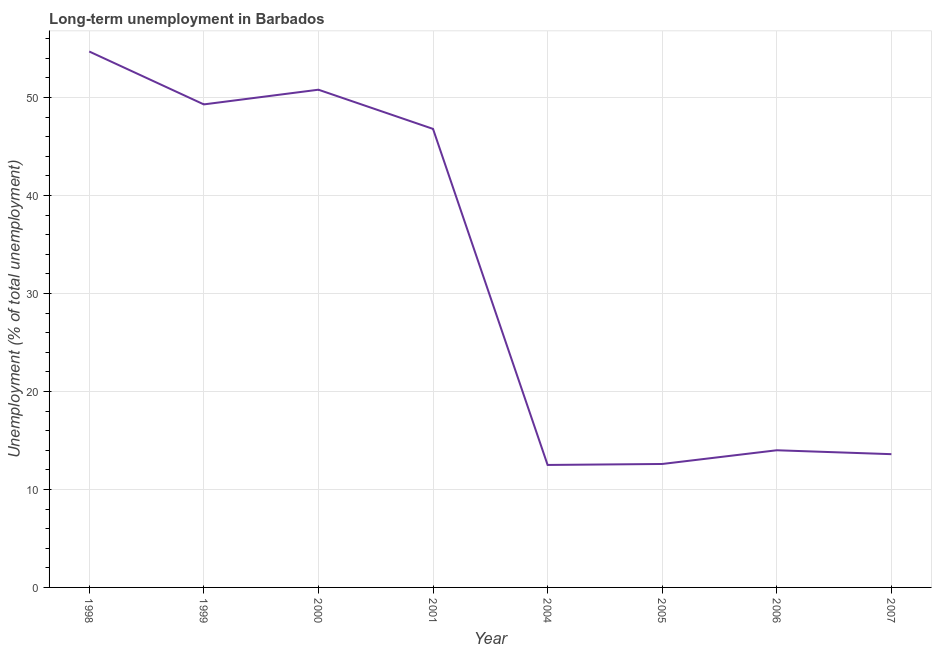What is the long-term unemployment in 1999?
Ensure brevity in your answer.  49.3. Across all years, what is the maximum long-term unemployment?
Keep it short and to the point. 54.7. Across all years, what is the minimum long-term unemployment?
Your response must be concise. 12.5. In which year was the long-term unemployment minimum?
Your response must be concise. 2004. What is the sum of the long-term unemployment?
Your answer should be compact. 254.3. What is the difference between the long-term unemployment in 2006 and 2007?
Make the answer very short. 0.4. What is the average long-term unemployment per year?
Provide a short and direct response. 31.79. What is the median long-term unemployment?
Your response must be concise. 30.4. What is the ratio of the long-term unemployment in 2004 to that in 2006?
Provide a succinct answer. 0.89. Is the long-term unemployment in 2000 less than that in 2007?
Ensure brevity in your answer.  No. What is the difference between the highest and the second highest long-term unemployment?
Ensure brevity in your answer.  3.9. Is the sum of the long-term unemployment in 1998 and 2007 greater than the maximum long-term unemployment across all years?
Offer a very short reply. Yes. What is the difference between the highest and the lowest long-term unemployment?
Keep it short and to the point. 42.2. In how many years, is the long-term unemployment greater than the average long-term unemployment taken over all years?
Make the answer very short. 4. Does the long-term unemployment monotonically increase over the years?
Your answer should be compact. No. How many years are there in the graph?
Keep it short and to the point. 8. Are the values on the major ticks of Y-axis written in scientific E-notation?
Offer a terse response. No. What is the title of the graph?
Keep it short and to the point. Long-term unemployment in Barbados. What is the label or title of the X-axis?
Provide a short and direct response. Year. What is the label or title of the Y-axis?
Provide a succinct answer. Unemployment (% of total unemployment). What is the Unemployment (% of total unemployment) of 1998?
Your response must be concise. 54.7. What is the Unemployment (% of total unemployment) in 1999?
Offer a terse response. 49.3. What is the Unemployment (% of total unemployment) in 2000?
Give a very brief answer. 50.8. What is the Unemployment (% of total unemployment) in 2001?
Offer a very short reply. 46.8. What is the Unemployment (% of total unemployment) in 2004?
Provide a short and direct response. 12.5. What is the Unemployment (% of total unemployment) of 2005?
Your answer should be very brief. 12.6. What is the Unemployment (% of total unemployment) of 2007?
Ensure brevity in your answer.  13.6. What is the difference between the Unemployment (% of total unemployment) in 1998 and 2000?
Offer a very short reply. 3.9. What is the difference between the Unemployment (% of total unemployment) in 1998 and 2001?
Give a very brief answer. 7.9. What is the difference between the Unemployment (% of total unemployment) in 1998 and 2004?
Offer a terse response. 42.2. What is the difference between the Unemployment (% of total unemployment) in 1998 and 2005?
Your answer should be very brief. 42.1. What is the difference between the Unemployment (% of total unemployment) in 1998 and 2006?
Provide a short and direct response. 40.7. What is the difference between the Unemployment (% of total unemployment) in 1998 and 2007?
Your answer should be compact. 41.1. What is the difference between the Unemployment (% of total unemployment) in 1999 and 2000?
Keep it short and to the point. -1.5. What is the difference between the Unemployment (% of total unemployment) in 1999 and 2001?
Give a very brief answer. 2.5. What is the difference between the Unemployment (% of total unemployment) in 1999 and 2004?
Make the answer very short. 36.8. What is the difference between the Unemployment (% of total unemployment) in 1999 and 2005?
Provide a short and direct response. 36.7. What is the difference between the Unemployment (% of total unemployment) in 1999 and 2006?
Give a very brief answer. 35.3. What is the difference between the Unemployment (% of total unemployment) in 1999 and 2007?
Provide a short and direct response. 35.7. What is the difference between the Unemployment (% of total unemployment) in 2000 and 2001?
Ensure brevity in your answer.  4. What is the difference between the Unemployment (% of total unemployment) in 2000 and 2004?
Ensure brevity in your answer.  38.3. What is the difference between the Unemployment (% of total unemployment) in 2000 and 2005?
Offer a very short reply. 38.2. What is the difference between the Unemployment (% of total unemployment) in 2000 and 2006?
Provide a short and direct response. 36.8. What is the difference between the Unemployment (% of total unemployment) in 2000 and 2007?
Make the answer very short. 37.2. What is the difference between the Unemployment (% of total unemployment) in 2001 and 2004?
Ensure brevity in your answer.  34.3. What is the difference between the Unemployment (% of total unemployment) in 2001 and 2005?
Provide a succinct answer. 34.2. What is the difference between the Unemployment (% of total unemployment) in 2001 and 2006?
Keep it short and to the point. 32.8. What is the difference between the Unemployment (% of total unemployment) in 2001 and 2007?
Provide a succinct answer. 33.2. What is the difference between the Unemployment (% of total unemployment) in 2004 and 2006?
Your response must be concise. -1.5. What is the difference between the Unemployment (% of total unemployment) in 2005 and 2006?
Provide a succinct answer. -1.4. What is the difference between the Unemployment (% of total unemployment) in 2005 and 2007?
Provide a short and direct response. -1. What is the ratio of the Unemployment (% of total unemployment) in 1998 to that in 1999?
Your response must be concise. 1.11. What is the ratio of the Unemployment (% of total unemployment) in 1998 to that in 2000?
Keep it short and to the point. 1.08. What is the ratio of the Unemployment (% of total unemployment) in 1998 to that in 2001?
Give a very brief answer. 1.17. What is the ratio of the Unemployment (% of total unemployment) in 1998 to that in 2004?
Provide a short and direct response. 4.38. What is the ratio of the Unemployment (% of total unemployment) in 1998 to that in 2005?
Your answer should be very brief. 4.34. What is the ratio of the Unemployment (% of total unemployment) in 1998 to that in 2006?
Offer a terse response. 3.91. What is the ratio of the Unemployment (% of total unemployment) in 1998 to that in 2007?
Give a very brief answer. 4.02. What is the ratio of the Unemployment (% of total unemployment) in 1999 to that in 2001?
Your answer should be compact. 1.05. What is the ratio of the Unemployment (% of total unemployment) in 1999 to that in 2004?
Keep it short and to the point. 3.94. What is the ratio of the Unemployment (% of total unemployment) in 1999 to that in 2005?
Provide a short and direct response. 3.91. What is the ratio of the Unemployment (% of total unemployment) in 1999 to that in 2006?
Provide a short and direct response. 3.52. What is the ratio of the Unemployment (% of total unemployment) in 1999 to that in 2007?
Your answer should be compact. 3.62. What is the ratio of the Unemployment (% of total unemployment) in 2000 to that in 2001?
Your response must be concise. 1.08. What is the ratio of the Unemployment (% of total unemployment) in 2000 to that in 2004?
Offer a very short reply. 4.06. What is the ratio of the Unemployment (% of total unemployment) in 2000 to that in 2005?
Provide a short and direct response. 4.03. What is the ratio of the Unemployment (% of total unemployment) in 2000 to that in 2006?
Make the answer very short. 3.63. What is the ratio of the Unemployment (% of total unemployment) in 2000 to that in 2007?
Your response must be concise. 3.73. What is the ratio of the Unemployment (% of total unemployment) in 2001 to that in 2004?
Give a very brief answer. 3.74. What is the ratio of the Unemployment (% of total unemployment) in 2001 to that in 2005?
Your response must be concise. 3.71. What is the ratio of the Unemployment (% of total unemployment) in 2001 to that in 2006?
Your answer should be compact. 3.34. What is the ratio of the Unemployment (% of total unemployment) in 2001 to that in 2007?
Provide a succinct answer. 3.44. What is the ratio of the Unemployment (% of total unemployment) in 2004 to that in 2006?
Give a very brief answer. 0.89. What is the ratio of the Unemployment (% of total unemployment) in 2004 to that in 2007?
Your answer should be very brief. 0.92. What is the ratio of the Unemployment (% of total unemployment) in 2005 to that in 2006?
Ensure brevity in your answer.  0.9. What is the ratio of the Unemployment (% of total unemployment) in 2005 to that in 2007?
Your answer should be compact. 0.93. What is the ratio of the Unemployment (% of total unemployment) in 2006 to that in 2007?
Your answer should be very brief. 1.03. 